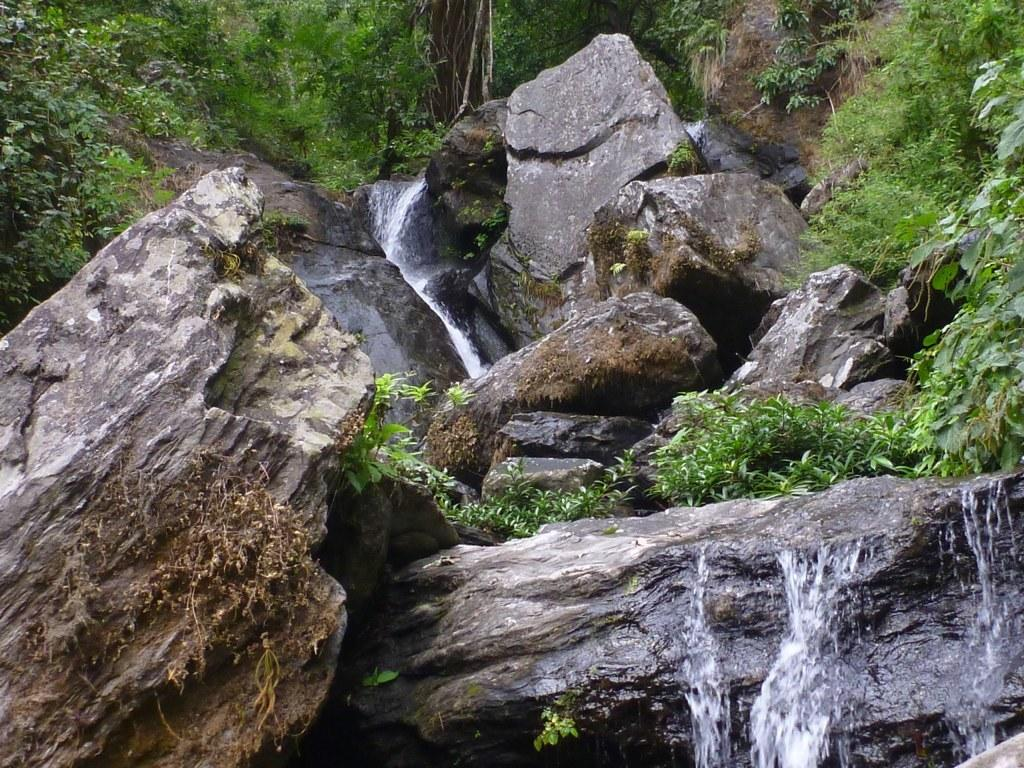What natural feature is the main subject of the image? There is a waterfall in the image. What type of geological formation can be seen in the image? Rocks are present in the image. What can be seen in the distance in the image? There are trees and grass visible in the background of the image. What time of day does the surprise occur in the image? There is no mention of a surprise or a specific time of day in the image. The image simply shows a waterfall, rocks, trees, and grass. 